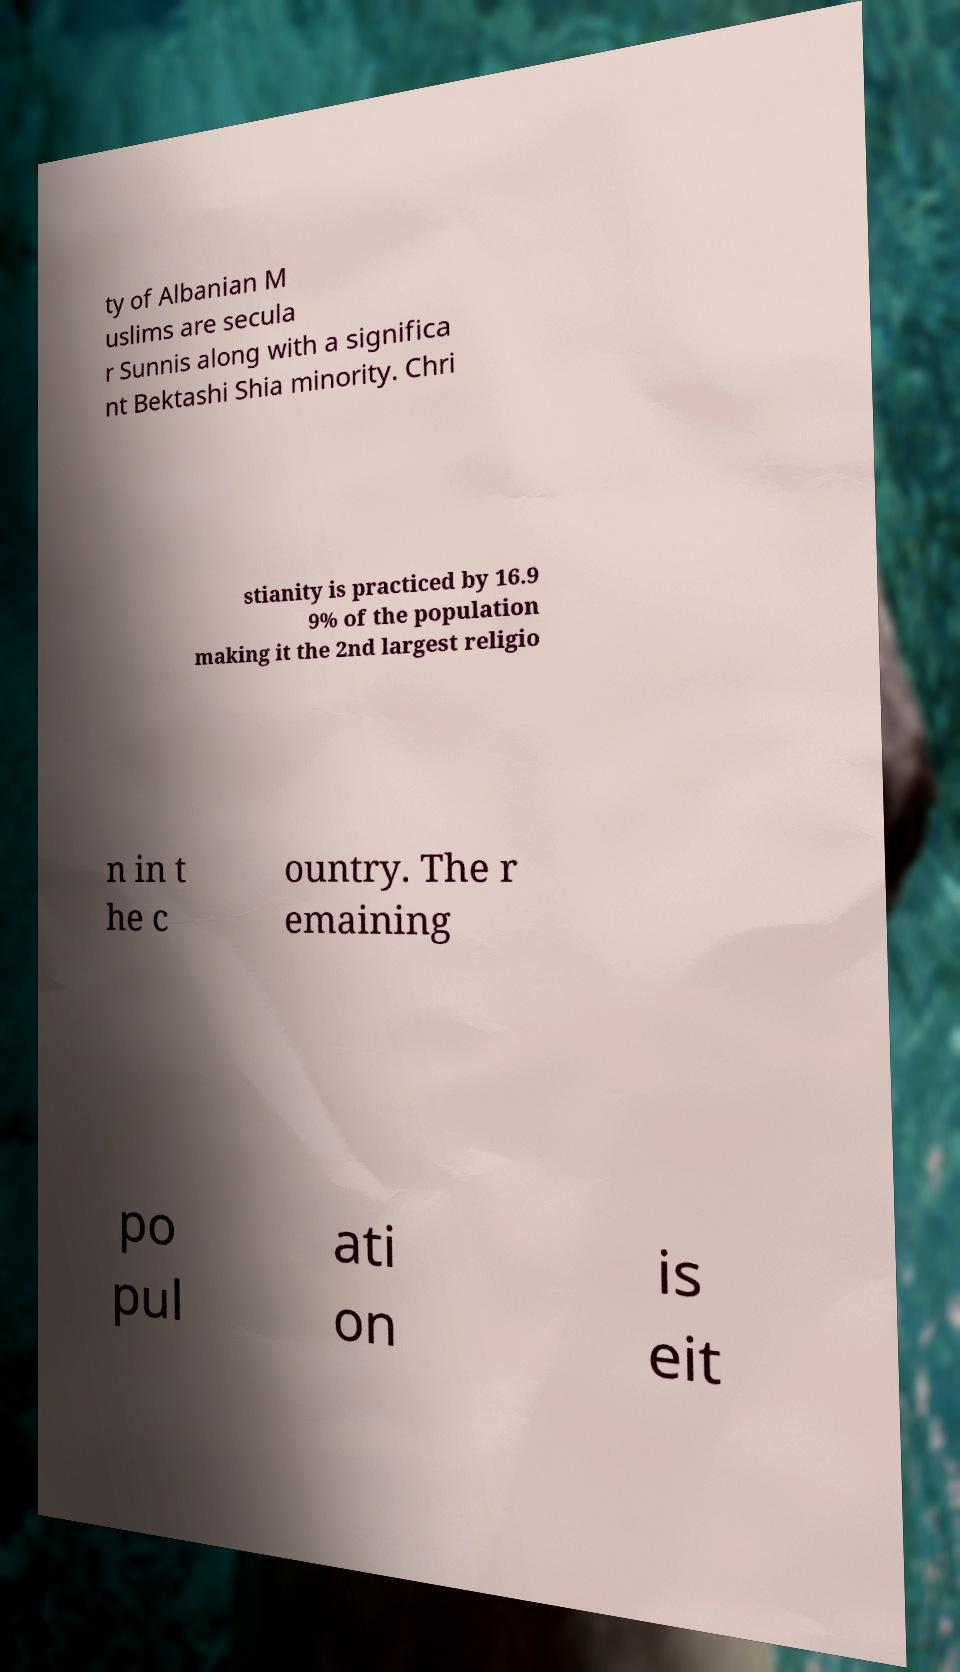What messages or text are displayed in this image? I need them in a readable, typed format. ty of Albanian M uslims are secula r Sunnis along with a significa nt Bektashi Shia minority. Chri stianity is practiced by 16.9 9% of the population making it the 2nd largest religio n in t he c ountry. The r emaining po pul ati on is eit 